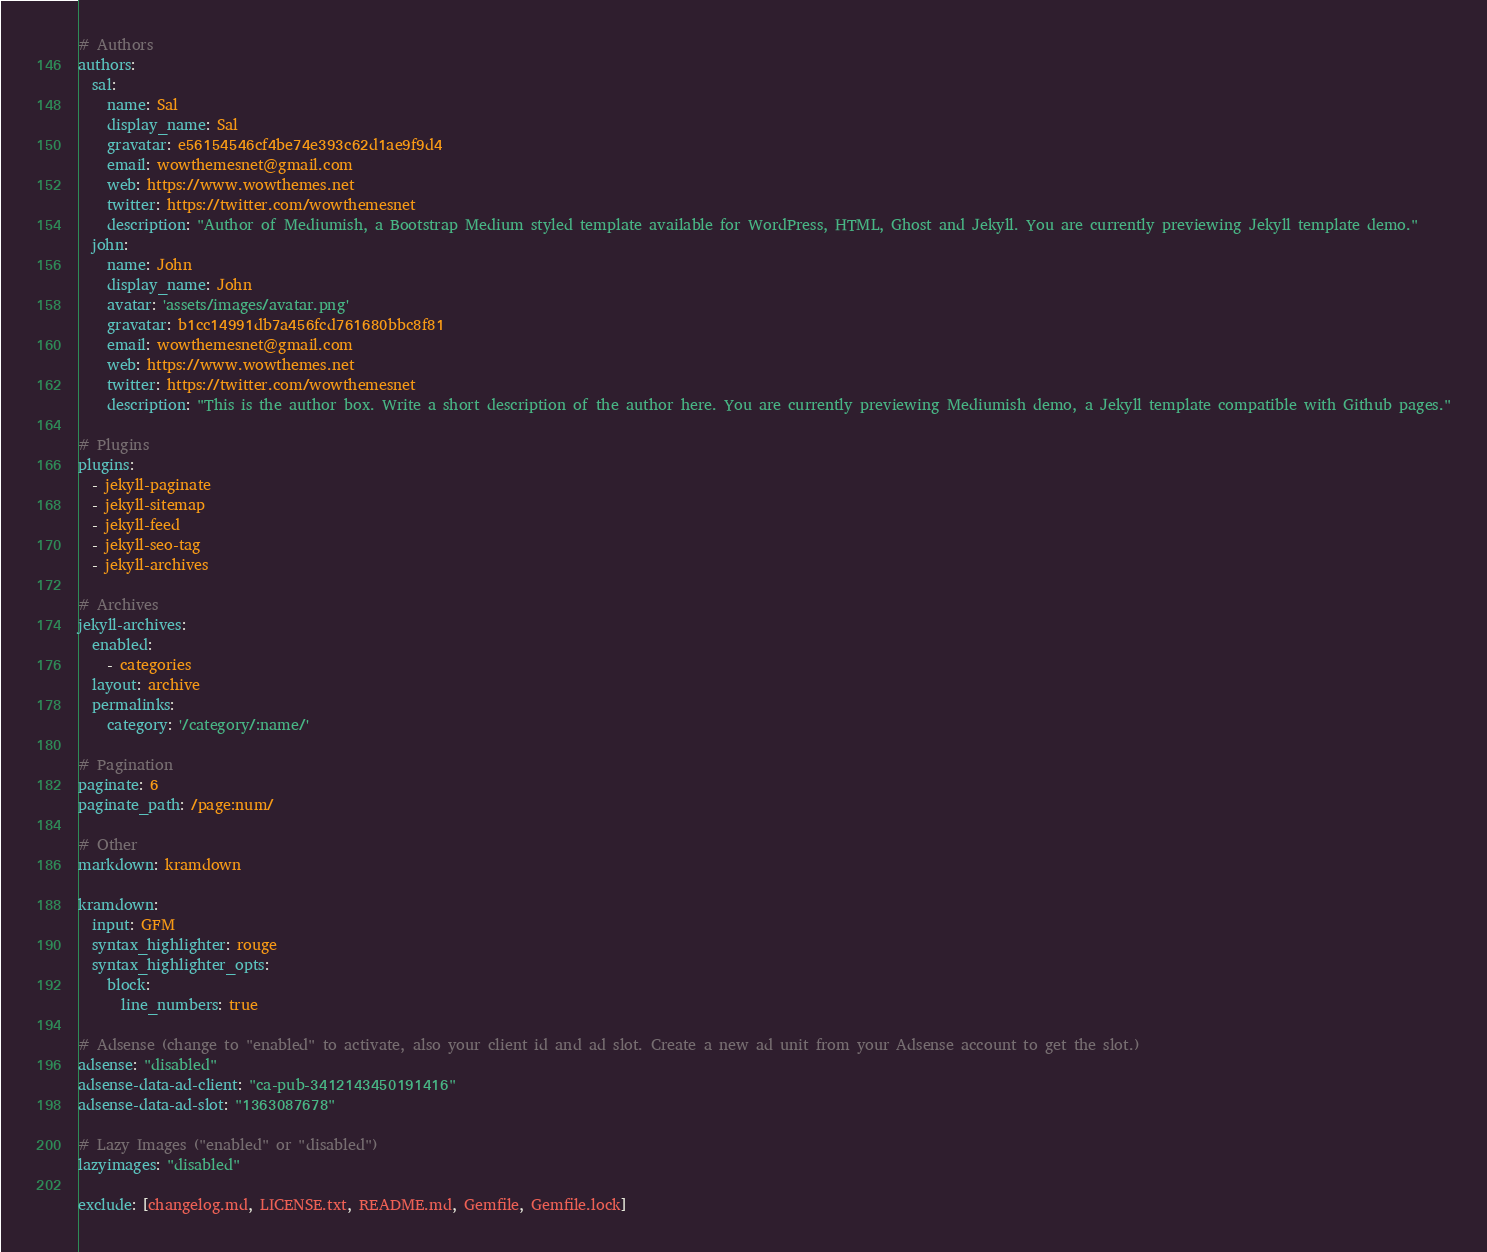<code> <loc_0><loc_0><loc_500><loc_500><_YAML_>
# Authors
authors:
  sal:
    name: Sal
    display_name: Sal
    gravatar: e56154546cf4be74e393c62d1ae9f9d4
    email: wowthemesnet@gmail.com
    web: https://www.wowthemes.net
    twitter: https://twitter.com/wowthemesnet
    description: "Author of Mediumish, a Bootstrap Medium styled template available for WordPress, HTML, Ghost and Jekyll. You are currently previewing Jekyll template demo."
  john:
    name: John
    display_name: John    
    avatar: 'assets/images/avatar.png'
    gravatar: b1cc14991db7a456fcd761680bbc8f81
    email: wowthemesnet@gmail.com
    web: https://www.wowthemes.net
    twitter: https://twitter.com/wowthemesnet
    description: "This is the author box. Write a short description of the author here. You are currently previewing Mediumish demo, a Jekyll template compatible with Github pages."

# Plugins
plugins:
  - jekyll-paginate
  - jekyll-sitemap
  - jekyll-feed
  - jekyll-seo-tag
  - jekyll-archives
    
# Archives
jekyll-archives:
  enabled:
    - categories
  layout: archive
  permalinks:
    category: '/category/:name/'
    
# Pagination 
paginate: 6
paginate_path: /page:num/
    
# Other
markdown: kramdown

kramdown:
  input: GFM
  syntax_highlighter: rouge
  syntax_highlighter_opts:
    block:
      line_numbers: true

# Adsense (change to "enabled" to activate, also your client id and ad slot. Create a new ad unit from your Adsense account to get the slot.)
adsense: "disabled"
adsense-data-ad-client: "ca-pub-3412143450191416"
adsense-data-ad-slot: "1363087678"

# Lazy Images ("enabled" or "disabled")
lazyimages: "disabled"

exclude: [changelog.md, LICENSE.txt, README.md, Gemfile, Gemfile.lock]
</code> 